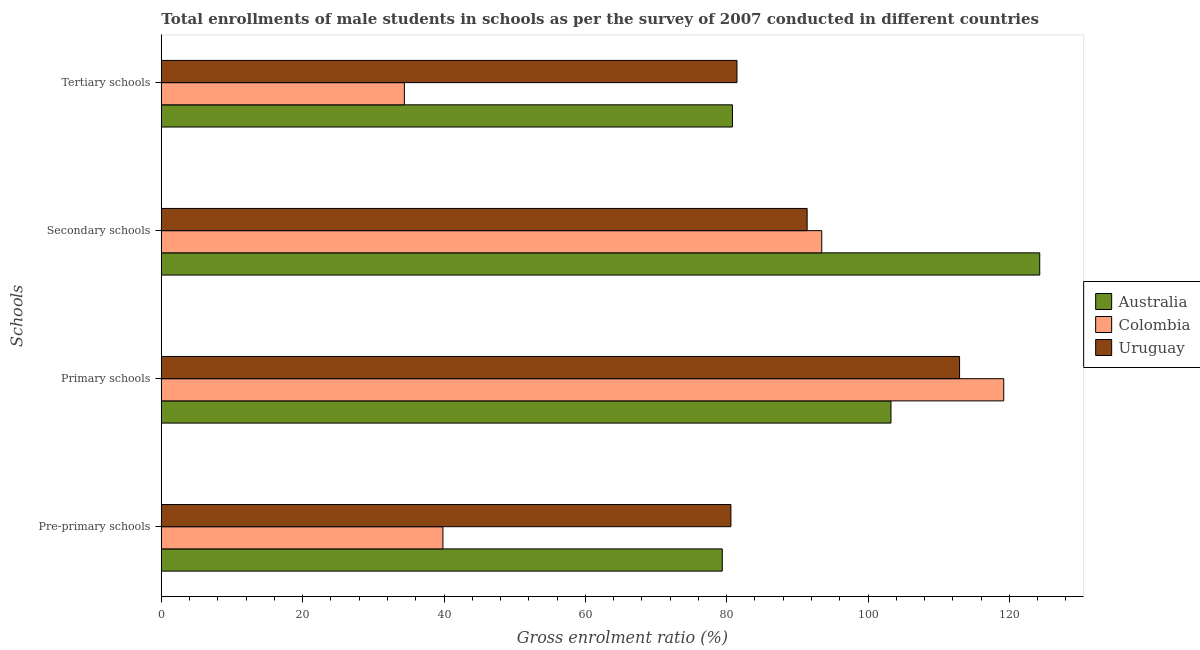Are the number of bars per tick equal to the number of legend labels?
Your answer should be compact. Yes. How many bars are there on the 3rd tick from the top?
Provide a succinct answer. 3. What is the label of the 3rd group of bars from the top?
Offer a terse response. Primary schools. What is the gross enrolment ratio(male) in secondary schools in Uruguay?
Your answer should be very brief. 91.38. Across all countries, what is the maximum gross enrolment ratio(male) in pre-primary schools?
Your answer should be very brief. 80.6. Across all countries, what is the minimum gross enrolment ratio(male) in pre-primary schools?
Offer a terse response. 39.85. In which country was the gross enrolment ratio(male) in pre-primary schools maximum?
Make the answer very short. Uruguay. In which country was the gross enrolment ratio(male) in tertiary schools minimum?
Your response must be concise. Colombia. What is the total gross enrolment ratio(male) in secondary schools in the graph?
Offer a very short reply. 309.13. What is the difference between the gross enrolment ratio(male) in secondary schools in Colombia and that in Uruguay?
Provide a succinct answer. 2.07. What is the difference between the gross enrolment ratio(male) in pre-primary schools in Uruguay and the gross enrolment ratio(male) in secondary schools in Australia?
Make the answer very short. -43.7. What is the average gross enrolment ratio(male) in tertiary schools per country?
Ensure brevity in your answer.  65.56. What is the difference between the gross enrolment ratio(male) in secondary schools and gross enrolment ratio(male) in pre-primary schools in Colombia?
Make the answer very short. 53.61. In how many countries, is the gross enrolment ratio(male) in tertiary schools greater than 72 %?
Your response must be concise. 2. What is the ratio of the gross enrolment ratio(male) in tertiary schools in Colombia to that in Uruguay?
Make the answer very short. 0.42. Is the gross enrolment ratio(male) in tertiary schools in Colombia less than that in Australia?
Your response must be concise. Yes. What is the difference between the highest and the second highest gross enrolment ratio(male) in primary schools?
Your response must be concise. 6.25. What is the difference between the highest and the lowest gross enrolment ratio(male) in tertiary schools?
Your response must be concise. 47.06. Is the sum of the gross enrolment ratio(male) in tertiary schools in Uruguay and Australia greater than the maximum gross enrolment ratio(male) in primary schools across all countries?
Provide a short and direct response. Yes. What does the 3rd bar from the top in Pre-primary schools represents?
Your response must be concise. Australia. What does the 3rd bar from the bottom in Secondary schools represents?
Offer a very short reply. Uruguay. What is the difference between two consecutive major ticks on the X-axis?
Your answer should be compact. 20. Are the values on the major ticks of X-axis written in scientific E-notation?
Keep it short and to the point. No. Does the graph contain grids?
Your response must be concise. No. How many legend labels are there?
Offer a terse response. 3. How are the legend labels stacked?
Your response must be concise. Vertical. What is the title of the graph?
Provide a succinct answer. Total enrollments of male students in schools as per the survey of 2007 conducted in different countries. What is the label or title of the X-axis?
Your answer should be very brief. Gross enrolment ratio (%). What is the label or title of the Y-axis?
Make the answer very short. Schools. What is the Gross enrolment ratio (%) in Australia in Pre-primary schools?
Your answer should be very brief. 79.38. What is the Gross enrolment ratio (%) of Colombia in Pre-primary schools?
Make the answer very short. 39.85. What is the Gross enrolment ratio (%) of Uruguay in Pre-primary schools?
Give a very brief answer. 80.6. What is the Gross enrolment ratio (%) of Australia in Primary schools?
Give a very brief answer. 103.25. What is the Gross enrolment ratio (%) of Colombia in Primary schools?
Give a very brief answer. 119.2. What is the Gross enrolment ratio (%) of Uruguay in Primary schools?
Offer a terse response. 112.95. What is the Gross enrolment ratio (%) in Australia in Secondary schools?
Make the answer very short. 124.29. What is the Gross enrolment ratio (%) in Colombia in Secondary schools?
Offer a terse response. 93.45. What is the Gross enrolment ratio (%) in Uruguay in Secondary schools?
Keep it short and to the point. 91.38. What is the Gross enrolment ratio (%) of Australia in Tertiary schools?
Your response must be concise. 80.82. What is the Gross enrolment ratio (%) of Colombia in Tertiary schools?
Offer a terse response. 34.39. What is the Gross enrolment ratio (%) of Uruguay in Tertiary schools?
Ensure brevity in your answer.  81.46. Across all Schools, what is the maximum Gross enrolment ratio (%) in Australia?
Provide a succinct answer. 124.29. Across all Schools, what is the maximum Gross enrolment ratio (%) of Colombia?
Provide a succinct answer. 119.2. Across all Schools, what is the maximum Gross enrolment ratio (%) in Uruguay?
Provide a short and direct response. 112.95. Across all Schools, what is the minimum Gross enrolment ratio (%) of Australia?
Give a very brief answer. 79.38. Across all Schools, what is the minimum Gross enrolment ratio (%) in Colombia?
Provide a succinct answer. 34.39. Across all Schools, what is the minimum Gross enrolment ratio (%) in Uruguay?
Provide a succinct answer. 80.6. What is the total Gross enrolment ratio (%) in Australia in the graph?
Keep it short and to the point. 387.73. What is the total Gross enrolment ratio (%) of Colombia in the graph?
Ensure brevity in your answer.  286.89. What is the total Gross enrolment ratio (%) of Uruguay in the graph?
Provide a succinct answer. 366.39. What is the difference between the Gross enrolment ratio (%) in Australia in Pre-primary schools and that in Primary schools?
Provide a succinct answer. -23.87. What is the difference between the Gross enrolment ratio (%) of Colombia in Pre-primary schools and that in Primary schools?
Provide a succinct answer. -79.35. What is the difference between the Gross enrolment ratio (%) in Uruguay in Pre-primary schools and that in Primary schools?
Keep it short and to the point. -32.36. What is the difference between the Gross enrolment ratio (%) of Australia in Pre-primary schools and that in Secondary schools?
Ensure brevity in your answer.  -44.92. What is the difference between the Gross enrolment ratio (%) of Colombia in Pre-primary schools and that in Secondary schools?
Your answer should be very brief. -53.61. What is the difference between the Gross enrolment ratio (%) in Uruguay in Pre-primary schools and that in Secondary schools?
Keep it short and to the point. -10.78. What is the difference between the Gross enrolment ratio (%) in Australia in Pre-primary schools and that in Tertiary schools?
Your answer should be very brief. -1.44. What is the difference between the Gross enrolment ratio (%) of Colombia in Pre-primary schools and that in Tertiary schools?
Your answer should be compact. 5.45. What is the difference between the Gross enrolment ratio (%) of Uruguay in Pre-primary schools and that in Tertiary schools?
Give a very brief answer. -0.86. What is the difference between the Gross enrolment ratio (%) of Australia in Primary schools and that in Secondary schools?
Your answer should be compact. -21.05. What is the difference between the Gross enrolment ratio (%) in Colombia in Primary schools and that in Secondary schools?
Offer a terse response. 25.75. What is the difference between the Gross enrolment ratio (%) in Uruguay in Primary schools and that in Secondary schools?
Make the answer very short. 21.57. What is the difference between the Gross enrolment ratio (%) of Australia in Primary schools and that in Tertiary schools?
Your answer should be very brief. 22.43. What is the difference between the Gross enrolment ratio (%) of Colombia in Primary schools and that in Tertiary schools?
Ensure brevity in your answer.  84.81. What is the difference between the Gross enrolment ratio (%) in Uruguay in Primary schools and that in Tertiary schools?
Provide a short and direct response. 31.5. What is the difference between the Gross enrolment ratio (%) of Australia in Secondary schools and that in Tertiary schools?
Ensure brevity in your answer.  43.48. What is the difference between the Gross enrolment ratio (%) in Colombia in Secondary schools and that in Tertiary schools?
Your response must be concise. 59.06. What is the difference between the Gross enrolment ratio (%) of Uruguay in Secondary schools and that in Tertiary schools?
Make the answer very short. 9.92. What is the difference between the Gross enrolment ratio (%) of Australia in Pre-primary schools and the Gross enrolment ratio (%) of Colombia in Primary schools?
Make the answer very short. -39.82. What is the difference between the Gross enrolment ratio (%) of Australia in Pre-primary schools and the Gross enrolment ratio (%) of Uruguay in Primary schools?
Your answer should be compact. -33.58. What is the difference between the Gross enrolment ratio (%) in Colombia in Pre-primary schools and the Gross enrolment ratio (%) in Uruguay in Primary schools?
Your response must be concise. -73.11. What is the difference between the Gross enrolment ratio (%) of Australia in Pre-primary schools and the Gross enrolment ratio (%) of Colombia in Secondary schools?
Provide a succinct answer. -14.07. What is the difference between the Gross enrolment ratio (%) in Australia in Pre-primary schools and the Gross enrolment ratio (%) in Uruguay in Secondary schools?
Your answer should be very brief. -12. What is the difference between the Gross enrolment ratio (%) in Colombia in Pre-primary schools and the Gross enrolment ratio (%) in Uruguay in Secondary schools?
Provide a short and direct response. -51.53. What is the difference between the Gross enrolment ratio (%) in Australia in Pre-primary schools and the Gross enrolment ratio (%) in Colombia in Tertiary schools?
Your answer should be compact. 44.98. What is the difference between the Gross enrolment ratio (%) in Australia in Pre-primary schools and the Gross enrolment ratio (%) in Uruguay in Tertiary schools?
Make the answer very short. -2.08. What is the difference between the Gross enrolment ratio (%) in Colombia in Pre-primary schools and the Gross enrolment ratio (%) in Uruguay in Tertiary schools?
Offer a very short reply. -41.61. What is the difference between the Gross enrolment ratio (%) of Australia in Primary schools and the Gross enrolment ratio (%) of Colombia in Secondary schools?
Make the answer very short. 9.79. What is the difference between the Gross enrolment ratio (%) of Australia in Primary schools and the Gross enrolment ratio (%) of Uruguay in Secondary schools?
Your answer should be very brief. 11.86. What is the difference between the Gross enrolment ratio (%) in Colombia in Primary schools and the Gross enrolment ratio (%) in Uruguay in Secondary schools?
Provide a short and direct response. 27.82. What is the difference between the Gross enrolment ratio (%) in Australia in Primary schools and the Gross enrolment ratio (%) in Colombia in Tertiary schools?
Give a very brief answer. 68.85. What is the difference between the Gross enrolment ratio (%) of Australia in Primary schools and the Gross enrolment ratio (%) of Uruguay in Tertiary schools?
Your response must be concise. 21.79. What is the difference between the Gross enrolment ratio (%) in Colombia in Primary schools and the Gross enrolment ratio (%) in Uruguay in Tertiary schools?
Your answer should be very brief. 37.74. What is the difference between the Gross enrolment ratio (%) of Australia in Secondary schools and the Gross enrolment ratio (%) of Colombia in Tertiary schools?
Ensure brevity in your answer.  89.9. What is the difference between the Gross enrolment ratio (%) in Australia in Secondary schools and the Gross enrolment ratio (%) in Uruguay in Tertiary schools?
Offer a terse response. 42.84. What is the difference between the Gross enrolment ratio (%) in Colombia in Secondary schools and the Gross enrolment ratio (%) in Uruguay in Tertiary schools?
Provide a succinct answer. 11.99. What is the average Gross enrolment ratio (%) of Australia per Schools?
Give a very brief answer. 96.93. What is the average Gross enrolment ratio (%) in Colombia per Schools?
Offer a terse response. 71.72. What is the average Gross enrolment ratio (%) in Uruguay per Schools?
Offer a very short reply. 91.6. What is the difference between the Gross enrolment ratio (%) in Australia and Gross enrolment ratio (%) in Colombia in Pre-primary schools?
Your response must be concise. 39.53. What is the difference between the Gross enrolment ratio (%) of Australia and Gross enrolment ratio (%) of Uruguay in Pre-primary schools?
Your answer should be very brief. -1.22. What is the difference between the Gross enrolment ratio (%) in Colombia and Gross enrolment ratio (%) in Uruguay in Pre-primary schools?
Keep it short and to the point. -40.75. What is the difference between the Gross enrolment ratio (%) in Australia and Gross enrolment ratio (%) in Colombia in Primary schools?
Your answer should be very brief. -15.96. What is the difference between the Gross enrolment ratio (%) in Australia and Gross enrolment ratio (%) in Uruguay in Primary schools?
Offer a very short reply. -9.71. What is the difference between the Gross enrolment ratio (%) of Colombia and Gross enrolment ratio (%) of Uruguay in Primary schools?
Offer a very short reply. 6.25. What is the difference between the Gross enrolment ratio (%) in Australia and Gross enrolment ratio (%) in Colombia in Secondary schools?
Make the answer very short. 30.84. What is the difference between the Gross enrolment ratio (%) in Australia and Gross enrolment ratio (%) in Uruguay in Secondary schools?
Give a very brief answer. 32.91. What is the difference between the Gross enrolment ratio (%) of Colombia and Gross enrolment ratio (%) of Uruguay in Secondary schools?
Offer a very short reply. 2.07. What is the difference between the Gross enrolment ratio (%) in Australia and Gross enrolment ratio (%) in Colombia in Tertiary schools?
Keep it short and to the point. 46.42. What is the difference between the Gross enrolment ratio (%) in Australia and Gross enrolment ratio (%) in Uruguay in Tertiary schools?
Make the answer very short. -0.64. What is the difference between the Gross enrolment ratio (%) in Colombia and Gross enrolment ratio (%) in Uruguay in Tertiary schools?
Give a very brief answer. -47.06. What is the ratio of the Gross enrolment ratio (%) in Australia in Pre-primary schools to that in Primary schools?
Provide a succinct answer. 0.77. What is the ratio of the Gross enrolment ratio (%) in Colombia in Pre-primary schools to that in Primary schools?
Your answer should be compact. 0.33. What is the ratio of the Gross enrolment ratio (%) in Uruguay in Pre-primary schools to that in Primary schools?
Your response must be concise. 0.71. What is the ratio of the Gross enrolment ratio (%) in Australia in Pre-primary schools to that in Secondary schools?
Offer a terse response. 0.64. What is the ratio of the Gross enrolment ratio (%) in Colombia in Pre-primary schools to that in Secondary schools?
Offer a terse response. 0.43. What is the ratio of the Gross enrolment ratio (%) in Uruguay in Pre-primary schools to that in Secondary schools?
Give a very brief answer. 0.88. What is the ratio of the Gross enrolment ratio (%) of Australia in Pre-primary schools to that in Tertiary schools?
Provide a short and direct response. 0.98. What is the ratio of the Gross enrolment ratio (%) of Colombia in Pre-primary schools to that in Tertiary schools?
Offer a terse response. 1.16. What is the ratio of the Gross enrolment ratio (%) of Australia in Primary schools to that in Secondary schools?
Your response must be concise. 0.83. What is the ratio of the Gross enrolment ratio (%) in Colombia in Primary schools to that in Secondary schools?
Give a very brief answer. 1.28. What is the ratio of the Gross enrolment ratio (%) in Uruguay in Primary schools to that in Secondary schools?
Keep it short and to the point. 1.24. What is the ratio of the Gross enrolment ratio (%) in Australia in Primary schools to that in Tertiary schools?
Provide a succinct answer. 1.28. What is the ratio of the Gross enrolment ratio (%) of Colombia in Primary schools to that in Tertiary schools?
Your answer should be very brief. 3.47. What is the ratio of the Gross enrolment ratio (%) of Uruguay in Primary schools to that in Tertiary schools?
Your response must be concise. 1.39. What is the ratio of the Gross enrolment ratio (%) in Australia in Secondary schools to that in Tertiary schools?
Keep it short and to the point. 1.54. What is the ratio of the Gross enrolment ratio (%) in Colombia in Secondary schools to that in Tertiary schools?
Your response must be concise. 2.72. What is the ratio of the Gross enrolment ratio (%) in Uruguay in Secondary schools to that in Tertiary schools?
Give a very brief answer. 1.12. What is the difference between the highest and the second highest Gross enrolment ratio (%) of Australia?
Keep it short and to the point. 21.05. What is the difference between the highest and the second highest Gross enrolment ratio (%) of Colombia?
Your answer should be compact. 25.75. What is the difference between the highest and the second highest Gross enrolment ratio (%) of Uruguay?
Make the answer very short. 21.57. What is the difference between the highest and the lowest Gross enrolment ratio (%) in Australia?
Make the answer very short. 44.92. What is the difference between the highest and the lowest Gross enrolment ratio (%) of Colombia?
Make the answer very short. 84.81. What is the difference between the highest and the lowest Gross enrolment ratio (%) in Uruguay?
Ensure brevity in your answer.  32.36. 